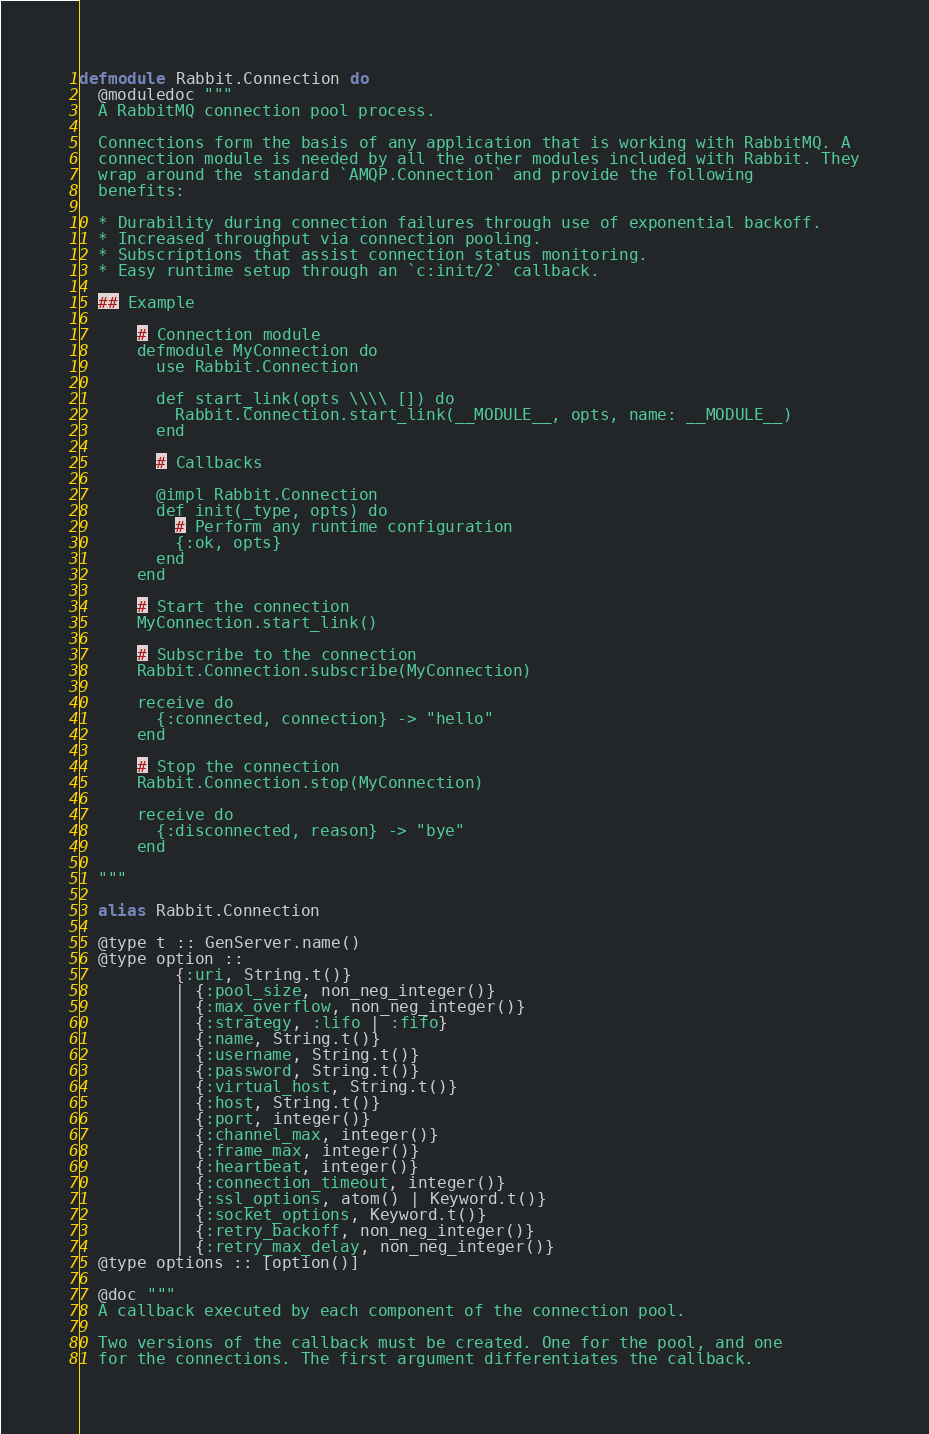Convert code to text. <code><loc_0><loc_0><loc_500><loc_500><_Elixir_>defmodule Rabbit.Connection do
  @moduledoc """
  A RabbitMQ connection pool process.

  Connections form the basis of any application that is working with RabbitMQ. A
  connection module is needed by all the other modules included with Rabbit. They
  wrap around the standard `AMQP.Connection` and provide the following
  benefits:

  * Durability during connection failures through use of exponential backoff.
  * Increased throughput via connection pooling.
  * Subscriptions that assist connection status monitoring.
  * Easy runtime setup through an `c:init/2` callback.

  ## Example

      # Connection module
      defmodule MyConnection do
        use Rabbit.Connection

        def start_link(opts \\\\ []) do
          Rabbit.Connection.start_link(__MODULE__, opts, name: __MODULE__)
        end

        # Callbacks

        @impl Rabbit.Connection
        def init(_type, opts) do
          # Perform any runtime configuration
          {:ok, opts}
        end
      end

      # Start the connection
      MyConnection.start_link()

      # Subscribe to the connection
      Rabbit.Connection.subscribe(MyConnection)

      receive do
        {:connected, connection} -> "hello"
      end

      # Stop the connection
      Rabbit.Connection.stop(MyConnection)

      receive do
        {:disconnected, reason} -> "bye"
      end

  """

  alias Rabbit.Connection

  @type t :: GenServer.name()
  @type option ::
          {:uri, String.t()}
          | {:pool_size, non_neg_integer()}
          | {:max_overflow, non_neg_integer()}
          | {:strategy, :lifo | :fifo}
          | {:name, String.t()}
          | {:username, String.t()}
          | {:password, String.t()}
          | {:virtual_host, String.t()}
          | {:host, String.t()}
          | {:port, integer()}
          | {:channel_max, integer()}
          | {:frame_max, integer()}
          | {:heartbeat, integer()}
          | {:connection_timeout, integer()}
          | {:ssl_options, atom() | Keyword.t()}
          | {:socket_options, Keyword.t()}
          | {:retry_backoff, non_neg_integer()}
          | {:retry_max_delay, non_neg_integer()}
  @type options :: [option()]

  @doc """
  A callback executed by each component of the connection pool.

  Two versions of the callback must be created. One for the pool, and one
  for the connections. The first argument differentiates the callback.
</code> 